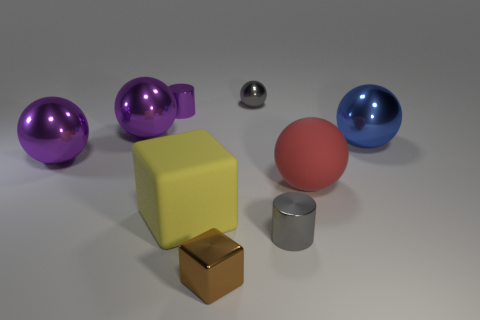Subtract all gray metal balls. How many balls are left? 4 Subtract all spheres. How many objects are left? 4 Subtract all purple balls. How many balls are left? 3 Subtract 2 cylinders. How many cylinders are left? 0 Subtract all gray cylinders. Subtract all green balls. How many cylinders are left? 1 Subtract all cyan balls. How many brown blocks are left? 1 Subtract all small cylinders. Subtract all brown metal cubes. How many objects are left? 6 Add 9 gray metallic balls. How many gray metallic balls are left? 10 Add 7 large green rubber blocks. How many large green rubber blocks exist? 7 Add 1 small blue metal spheres. How many objects exist? 10 